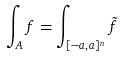Convert formula to latex. <formula><loc_0><loc_0><loc_500><loc_500>\int _ { A } f = \int _ { [ - a , a ] ^ { n } } \tilde { f }</formula> 